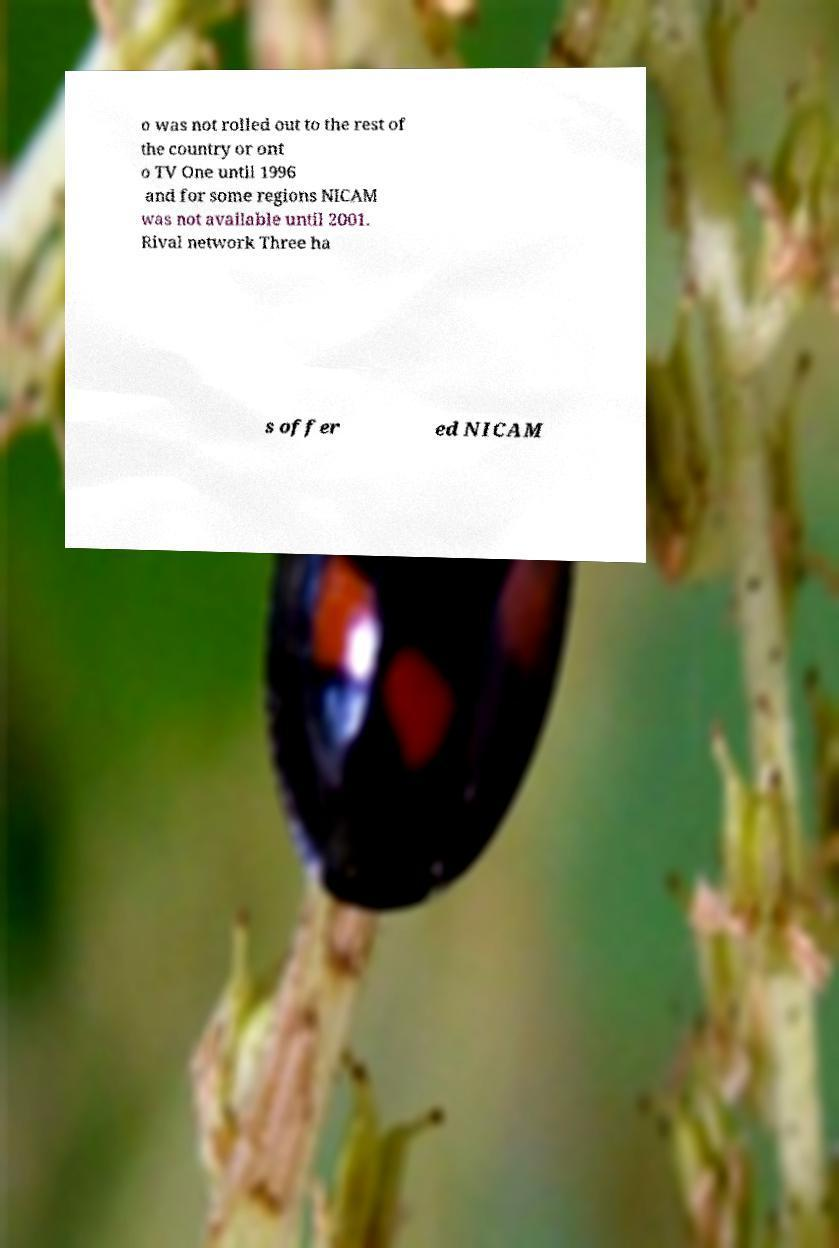Can you accurately transcribe the text from the provided image for me? o was not rolled out to the rest of the country or ont o TV One until 1996 and for some regions NICAM was not available until 2001. Rival network Three ha s offer ed NICAM 